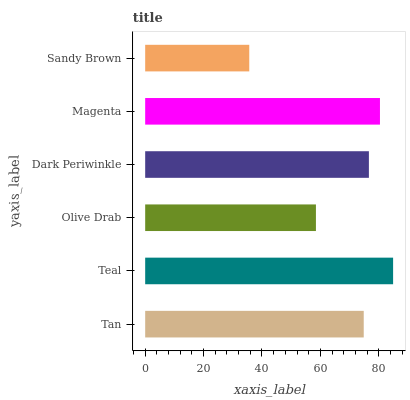Is Sandy Brown the minimum?
Answer yes or no. Yes. Is Teal the maximum?
Answer yes or no. Yes. Is Olive Drab the minimum?
Answer yes or no. No. Is Olive Drab the maximum?
Answer yes or no. No. Is Teal greater than Olive Drab?
Answer yes or no. Yes. Is Olive Drab less than Teal?
Answer yes or no. Yes. Is Olive Drab greater than Teal?
Answer yes or no. No. Is Teal less than Olive Drab?
Answer yes or no. No. Is Dark Periwinkle the high median?
Answer yes or no. Yes. Is Tan the low median?
Answer yes or no. Yes. Is Tan the high median?
Answer yes or no. No. Is Magenta the low median?
Answer yes or no. No. 